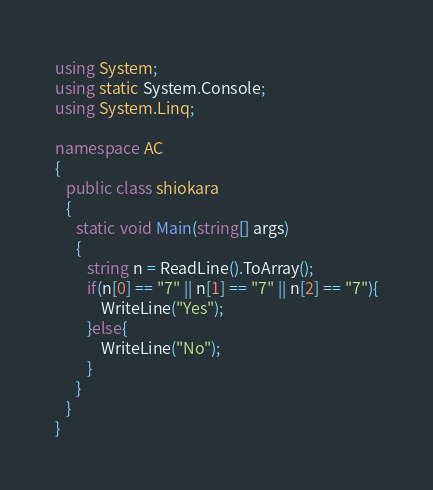<code> <loc_0><loc_0><loc_500><loc_500><_C#_>using System;
using static System.Console;
using System.Linq;

namespace AC
{
   public class shiokara
   {
      static void Main(string[] args)
      {
         string n = ReadLine().ToArray();
         if(n[0] == "7" || n[1] == "7" || n[2] == "7"){
             WriteLine("Yes");
         }else{
             WriteLine("No");
         }
      }
   }
}</code> 